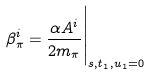Convert formula to latex. <formula><loc_0><loc_0><loc_500><loc_500>\beta _ { \pi } ^ { i } = \frac { \alpha A ^ { i } } { 2 m _ { \pi } } \Big | _ { s , t _ { 1 } , u _ { 1 } = 0 }</formula> 